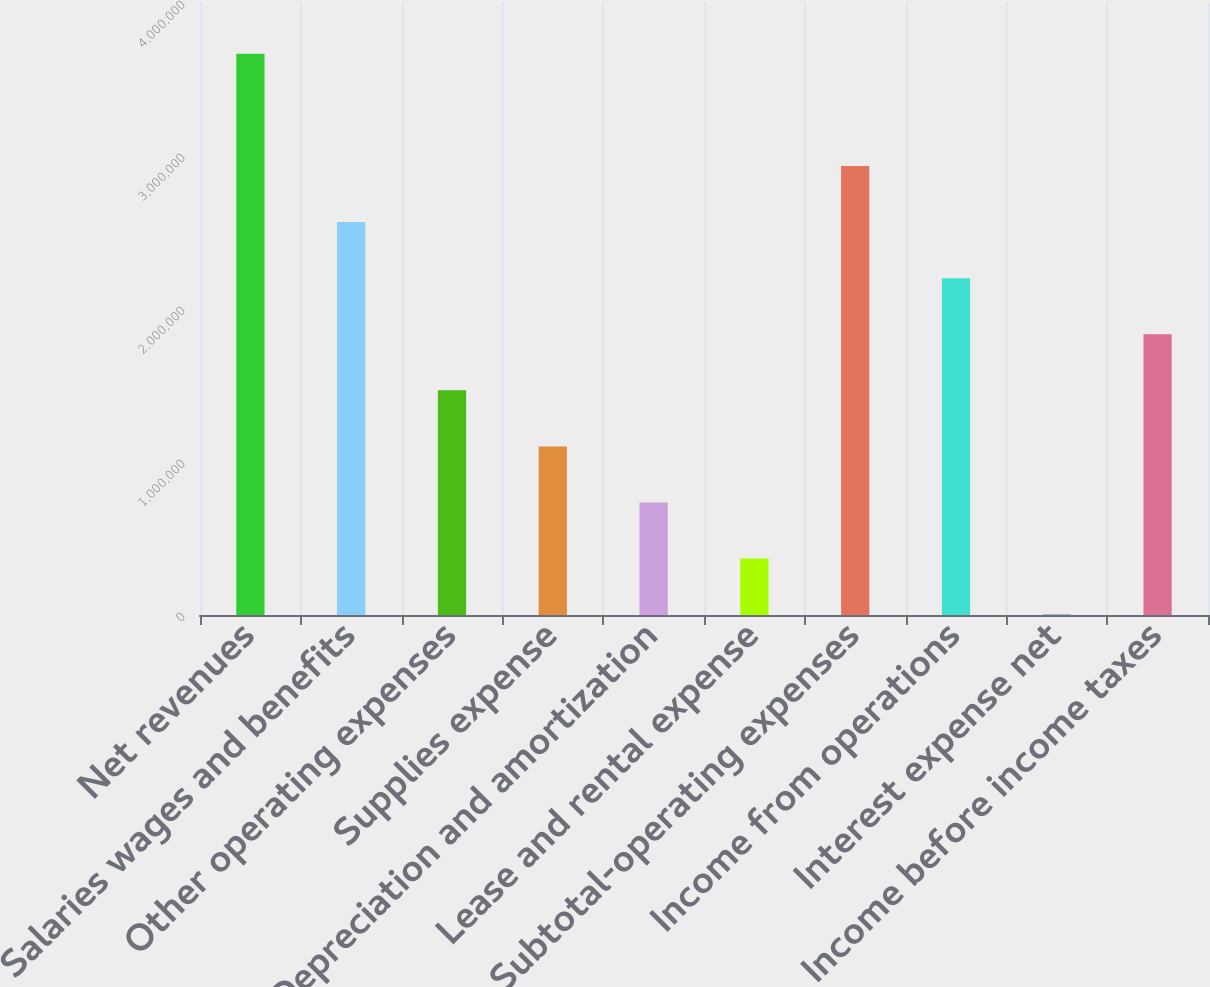Convert chart. <chart><loc_0><loc_0><loc_500><loc_500><bar_chart><fcel>Net revenues<fcel>Salaries wages and benefits<fcel>Other operating expenses<fcel>Supplies expense<fcel>Depreciation and amortization<fcel>Lease and rental expense<fcel>Subtotal-operating expenses<fcel>Income from operations<fcel>Interest expense net<fcel>Income before income taxes<nl><fcel>3.66797e+06<fcel>2.5682e+06<fcel>1.46843e+06<fcel>1.10185e+06<fcel>735257<fcel>368668<fcel>2.93479e+06<fcel>2.20161e+06<fcel>2079<fcel>1.83502e+06<nl></chart> 